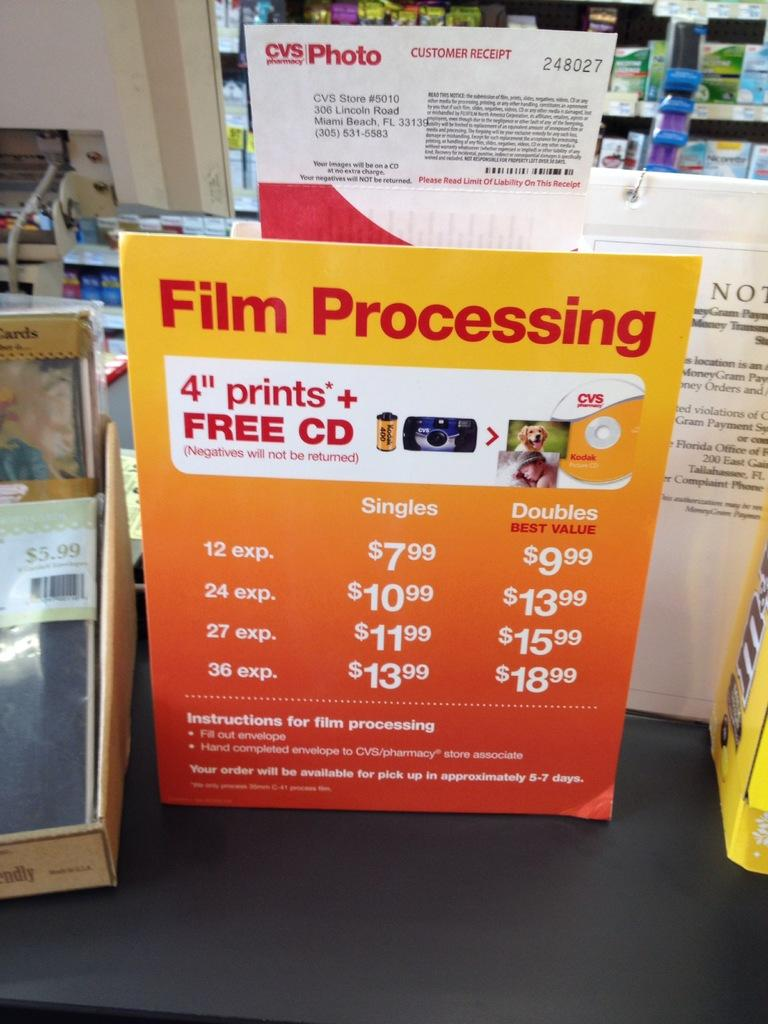<image>
Relay a brief, clear account of the picture shown. An advertisement at CVS for film processing offering a free cd. 